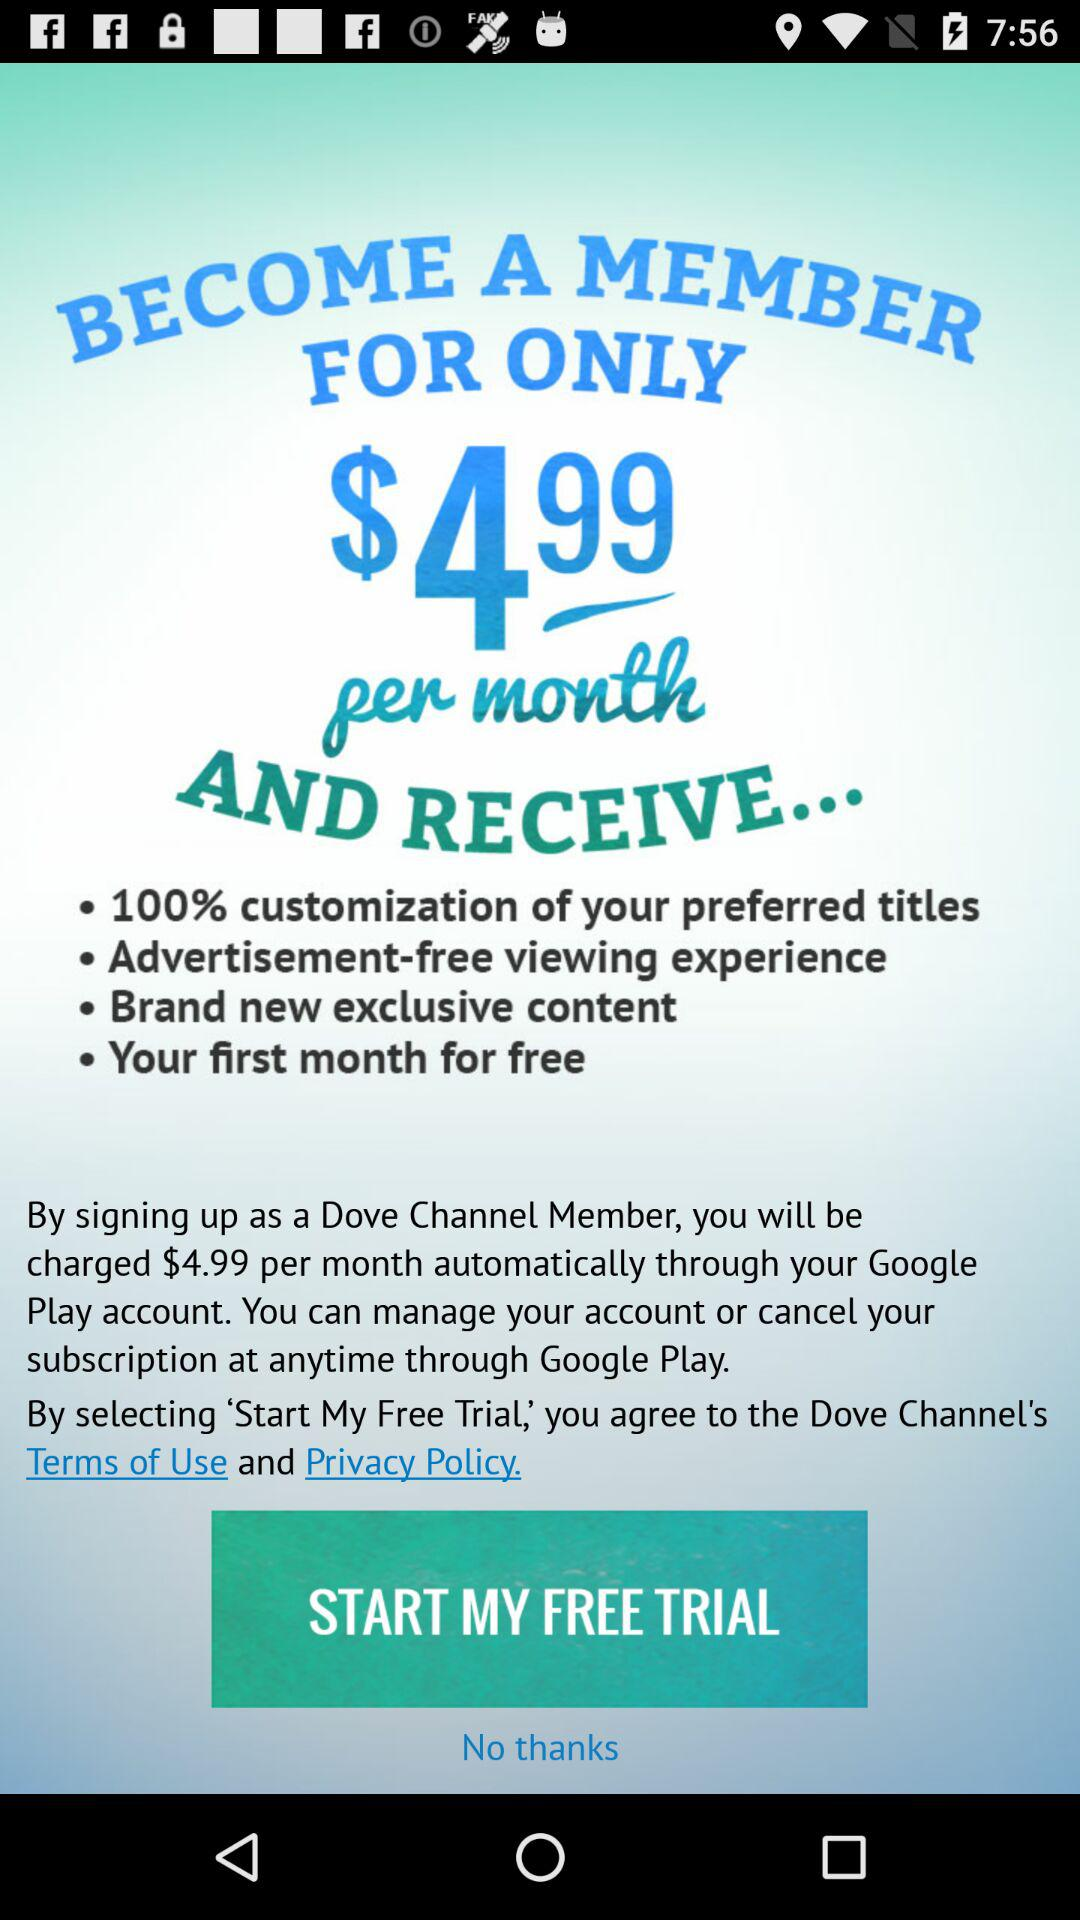How much is the monthly subscription?
Answer the question using a single word or phrase. $4.99 